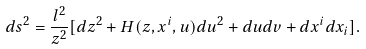<formula> <loc_0><loc_0><loc_500><loc_500>d s ^ { 2 } = \frac { l ^ { 2 } } { z ^ { 2 } } [ d z ^ { 2 } + H ( z , x ^ { i } , u ) d u ^ { 2 } + d u d v + d x ^ { i } d x _ { i } ] .</formula> 